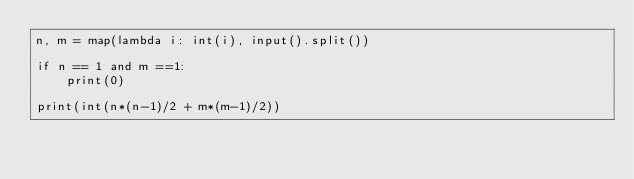Convert code to text. <code><loc_0><loc_0><loc_500><loc_500><_Python_>n, m = map(lambda i: int(i), input().split())

if n == 1 and m ==1:
    print(0)

print(int(n*(n-1)/2 + m*(m-1)/2))</code> 